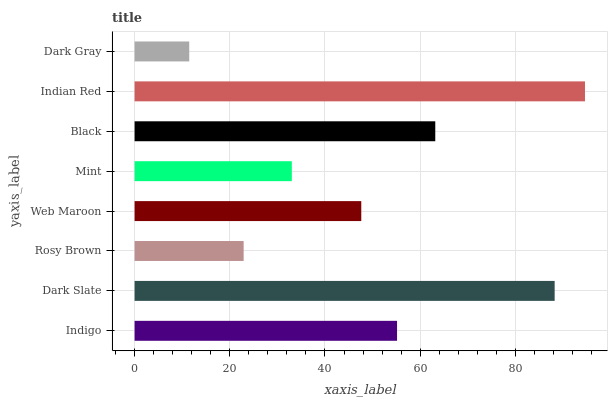Is Dark Gray the minimum?
Answer yes or no. Yes. Is Indian Red the maximum?
Answer yes or no. Yes. Is Dark Slate the minimum?
Answer yes or no. No. Is Dark Slate the maximum?
Answer yes or no. No. Is Dark Slate greater than Indigo?
Answer yes or no. Yes. Is Indigo less than Dark Slate?
Answer yes or no. Yes. Is Indigo greater than Dark Slate?
Answer yes or no. No. Is Dark Slate less than Indigo?
Answer yes or no. No. Is Indigo the high median?
Answer yes or no. Yes. Is Web Maroon the low median?
Answer yes or no. Yes. Is Black the high median?
Answer yes or no. No. Is Mint the low median?
Answer yes or no. No. 